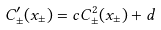<formula> <loc_0><loc_0><loc_500><loc_500>C ^ { \prime } _ { \pm } ( x _ { \pm } ) = c C _ { \pm } ^ { 2 } ( x _ { \pm } ) + d</formula> 